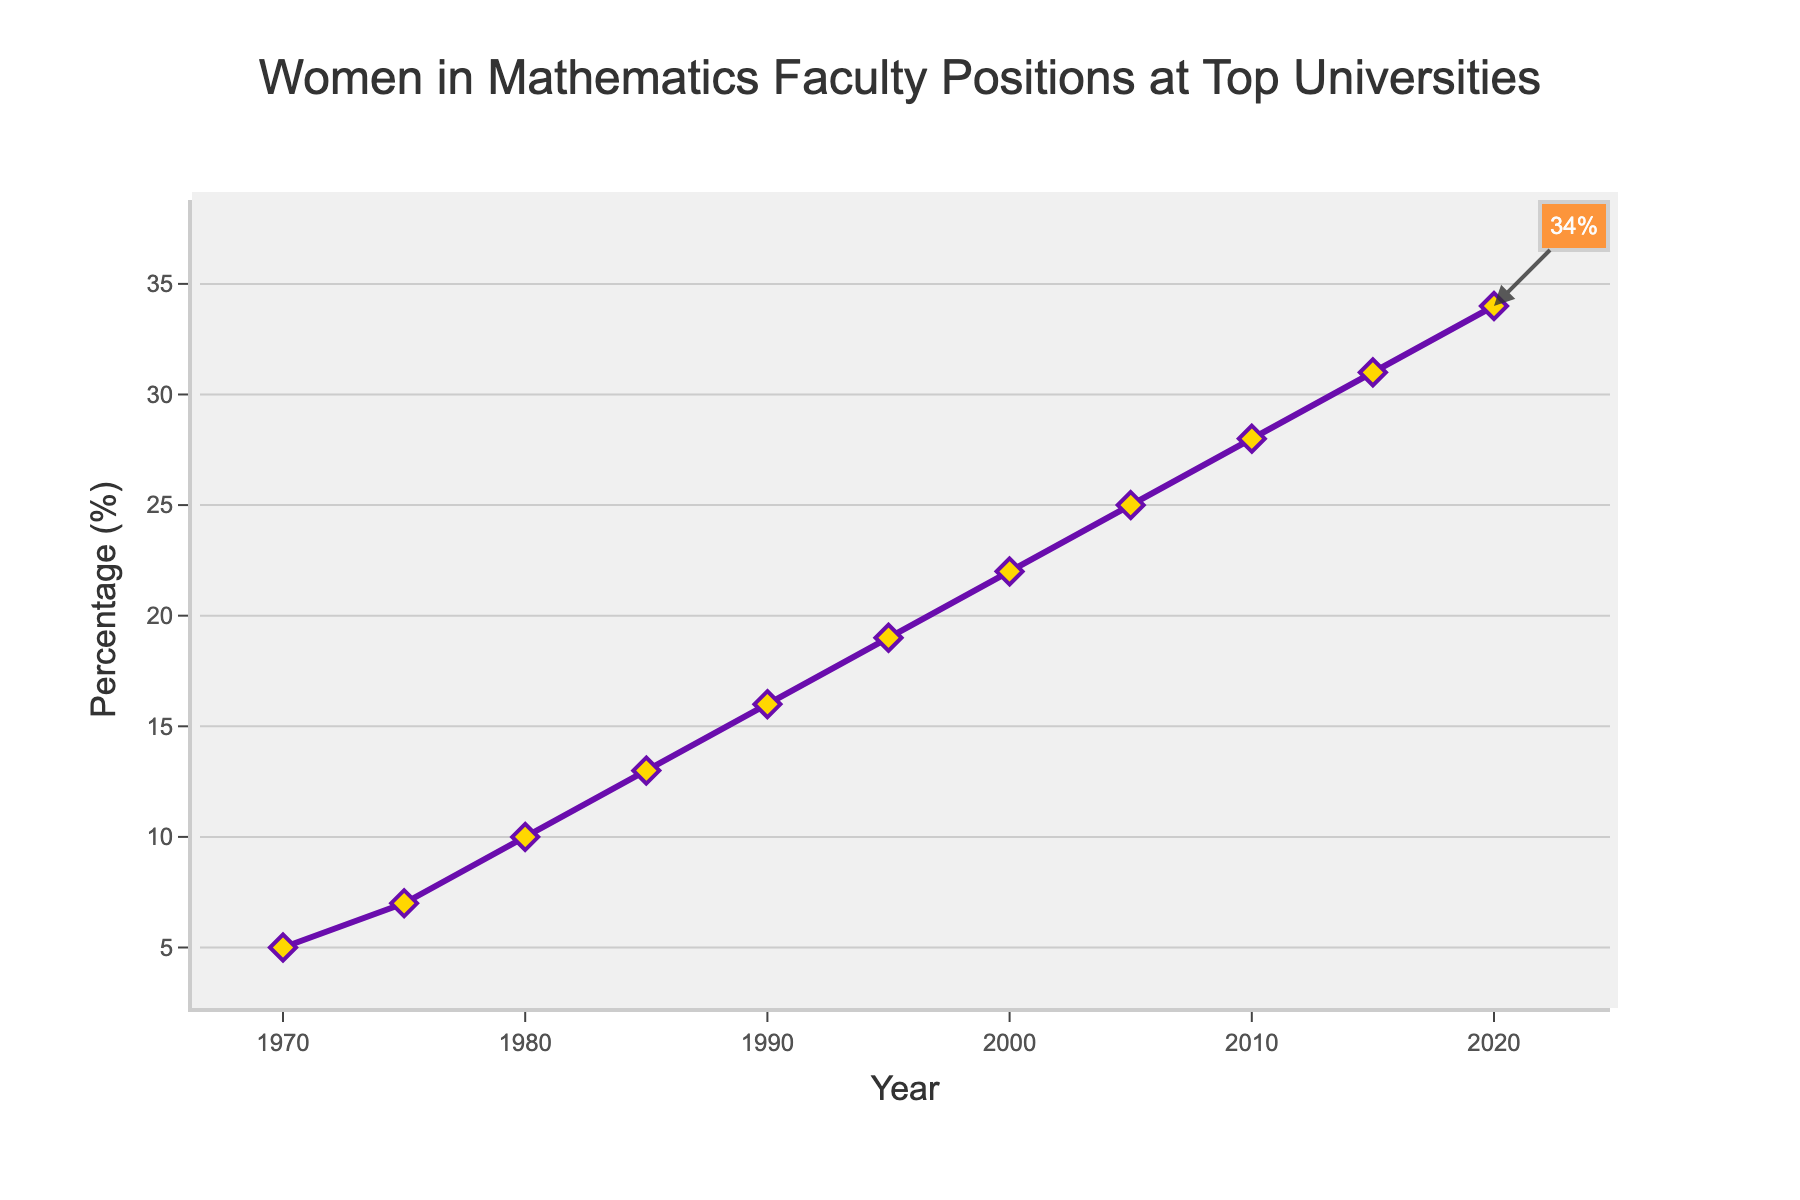What is the percentage of women in mathematics faculty positions in 2020? Refer to the point representing the year 2020 on the line chart and note the corresponding percentage on the y-axis.
Answer: 34% How does the percentage change from 1975 to 1980? Calculate the difference in percentages between the years 1975 and 1980. In 1975, the percentage is 7%, and in 1980, it is 10%. Therefore, the change is 10% - 7% = 3%.
Answer: 3% What is the average percentage of women in mathematics faculty positions for the years 1980, 1990, and 2000? Sum the percentages for the years 1980 (10%), 1990 (16%), and 2000 (22%) and divide by the number of data points. (10 + 16 + 22) / 3 = 48 / 3 = 16
Answer: 16% Was there any year in the data where the percentage of women did not increase from the previous recorded year? Scan the line chart from left to right and observe the trend of the percentages over the years. The line consistently rises, indicating an increase each year.
Answer: No What is the percentage increase in women in mathematics faculty positions between 1970 and 2020? Calculate the difference between the percentages in 2020 (34%) and 1970 (5%), then find the percentage increase. (34 - 5) = 29%.
Answer: 29% Between which consecutive years was the smallest increase in the percentage of women in mathematics faculty positions? Compare the differences in percentages for each consecutive pair of years. The smallest increase is between years 2015 (31%) and 2020 (34%), which is 3%.
Answer: 2015-2020 How does the progression trend look like visually over the years? Observe the overall shape and direction of the line chart. It shows a steady, upward trend with no downward dips.
Answer: Steady upward trend By how much did the percentage of women in mathematics faculty positions increase between the decades 1970-1980 and 2010-2020? For 1970-1980: 10% - 5% = 5%. For 2010-2020: 34% - 28% = 6%. Compare the increases from both decades.
Answer: 5% and 6% What is the visual color used for the plotted line and the markers? The line and markers are purple with golden-yellow diamond markers.
Answer: Purple and golden-yellow 